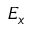<formula> <loc_0><loc_0><loc_500><loc_500>E _ { x }</formula> 